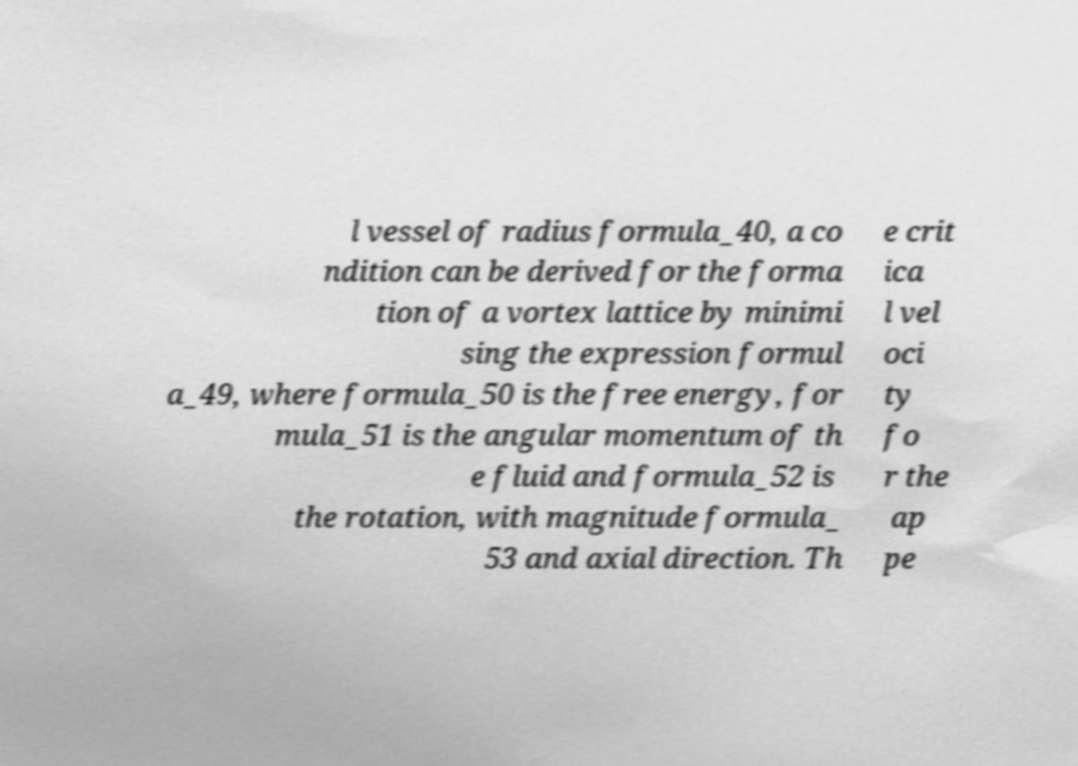I need the written content from this picture converted into text. Can you do that? l vessel of radius formula_40, a co ndition can be derived for the forma tion of a vortex lattice by minimi sing the expression formul a_49, where formula_50 is the free energy, for mula_51 is the angular momentum of th e fluid and formula_52 is the rotation, with magnitude formula_ 53 and axial direction. Th e crit ica l vel oci ty fo r the ap pe 